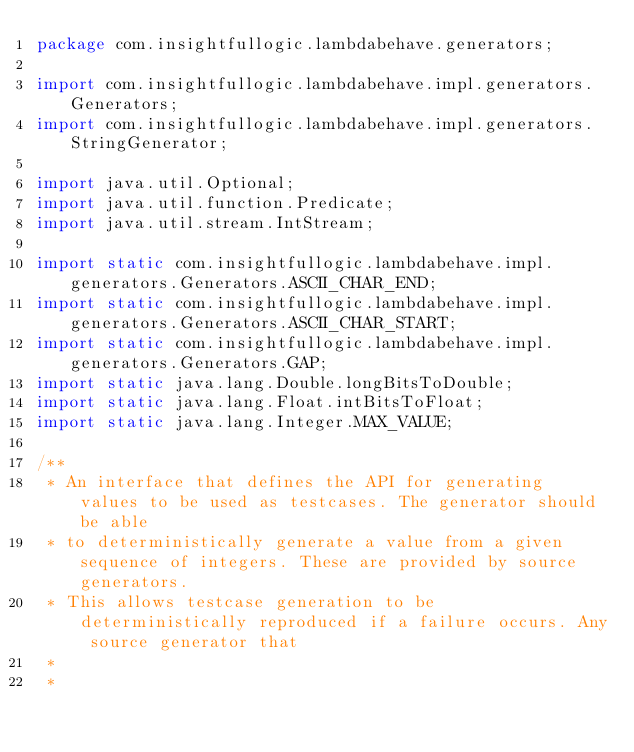<code> <loc_0><loc_0><loc_500><loc_500><_Java_>package com.insightfullogic.lambdabehave.generators;

import com.insightfullogic.lambdabehave.impl.generators.Generators;
import com.insightfullogic.lambdabehave.impl.generators.StringGenerator;

import java.util.Optional;
import java.util.function.Predicate;
import java.util.stream.IntStream;

import static com.insightfullogic.lambdabehave.impl.generators.Generators.ASCII_CHAR_END;
import static com.insightfullogic.lambdabehave.impl.generators.Generators.ASCII_CHAR_START;
import static com.insightfullogic.lambdabehave.impl.generators.Generators.GAP;
import static java.lang.Double.longBitsToDouble;
import static java.lang.Float.intBitsToFloat;
import static java.lang.Integer.MAX_VALUE;

/**
 * An interface that defines the API for generating values to be used as testcases. The generator should be able
 * to deterministically generate a value from a given sequence of integers. These are provided by source generators.
 * This allows testcase generation to be deterministically reproduced if a failure occurs. Any source generator that
 *
 *</code> 